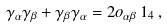<formula> <loc_0><loc_0><loc_500><loc_500>\gamma _ { \alpha } \gamma _ { \beta } + \gamma _ { \beta } \gamma _ { \alpha } = 2 o _ { \alpha \beta } \, { 1 } _ { 4 } \, ,</formula> 